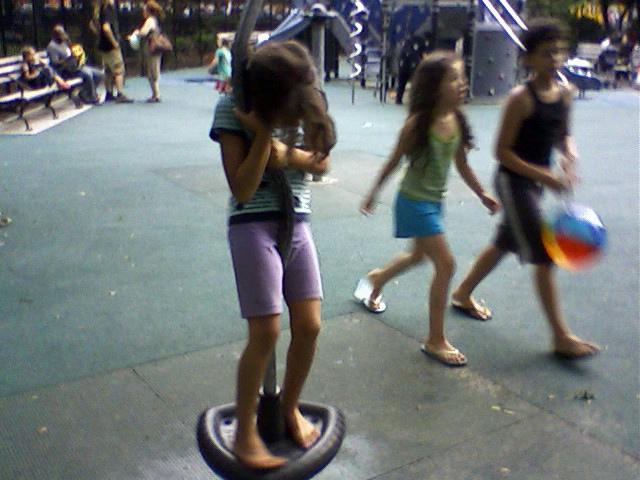Are the kids playing with toys?
Give a very brief answer. Yes. What type of footwear are the children on the right wearing?
Answer briefly. Flip flops. What is the little girl in the center standing on?
Give a very brief answer. Park bouncer. 